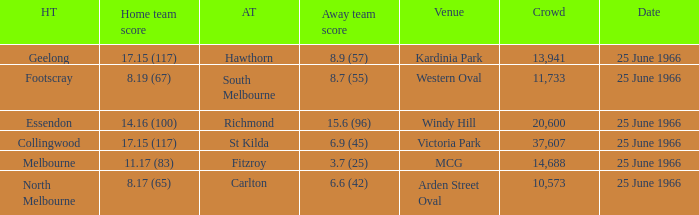When a home team scored 17.15 (117) and the away team scored 6.9 (45), what was the away team? St Kilda. 